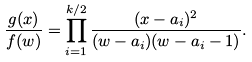Convert formula to latex. <formula><loc_0><loc_0><loc_500><loc_500>\frac { g ( x ) } { f ( w ) } = \prod _ { i = 1 } ^ { k / 2 } \frac { ( x - a _ { i } ) ^ { 2 } } { ( w - a _ { i } ) ( w - a _ { i } - 1 ) } .</formula> 